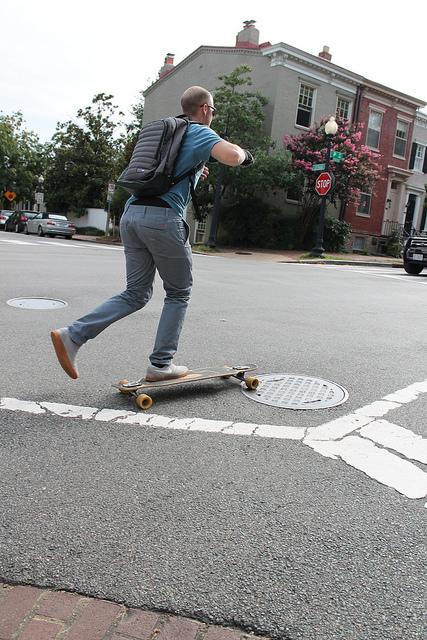Is the skateboard moving fast?
Quick response, please. No. What style of homes do you see here?
Concise answer only. Townhomes. Who is wearing a backpack?
Be succinct. Man. Is this man stunting?
Give a very brief answer. No. What color is his underwear?
Keep it brief. Black. Is the roadway straight or curved?
Short answer required. Curved. 